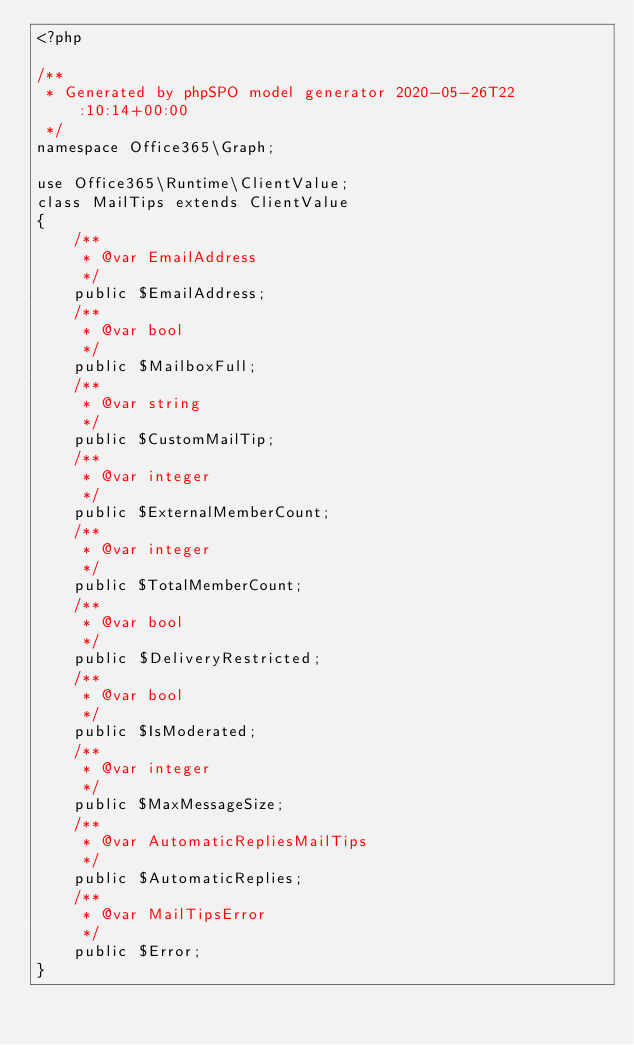Convert code to text. <code><loc_0><loc_0><loc_500><loc_500><_PHP_><?php

/**
 * Generated by phpSPO model generator 2020-05-26T22:10:14+00:00 
 */
namespace Office365\Graph;

use Office365\Runtime\ClientValue;
class MailTips extends ClientValue
{
    /**
     * @var EmailAddress
     */
    public $EmailAddress;
    /**
     * @var bool
     */
    public $MailboxFull;
    /**
     * @var string
     */
    public $CustomMailTip;
    /**
     * @var integer
     */
    public $ExternalMemberCount;
    /**
     * @var integer
     */
    public $TotalMemberCount;
    /**
     * @var bool
     */
    public $DeliveryRestricted;
    /**
     * @var bool
     */
    public $IsModerated;
    /**
     * @var integer
     */
    public $MaxMessageSize;
    /**
     * @var AutomaticRepliesMailTips
     */
    public $AutomaticReplies;
    /**
     * @var MailTipsError
     */
    public $Error;
}</code> 